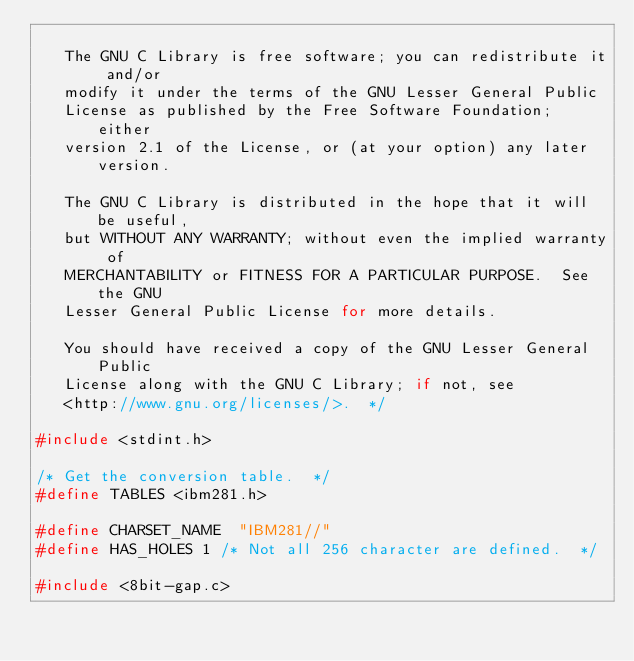Convert code to text. <code><loc_0><loc_0><loc_500><loc_500><_C_>
   The GNU C Library is free software; you can redistribute it and/or
   modify it under the terms of the GNU Lesser General Public
   License as published by the Free Software Foundation; either
   version 2.1 of the License, or (at your option) any later version.

   The GNU C Library is distributed in the hope that it will be useful,
   but WITHOUT ANY WARRANTY; without even the implied warranty of
   MERCHANTABILITY or FITNESS FOR A PARTICULAR PURPOSE.  See the GNU
   Lesser General Public License for more details.

   You should have received a copy of the GNU Lesser General Public
   License along with the GNU C Library; if not, see
   <http://www.gnu.org/licenses/>.  */

#include <stdint.h>

/* Get the conversion table.  */
#define TABLES <ibm281.h>

#define CHARSET_NAME	"IBM281//"
#define HAS_HOLES	1	/* Not all 256 character are defined.  */

#include <8bit-gap.c>
</code> 